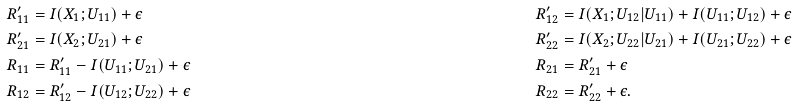<formula> <loc_0><loc_0><loc_500><loc_500>R _ { 1 1 } ^ { \prime } & = I ( X _ { 1 } ; U _ { 1 1 } ) + \epsilon & R _ { 1 2 } ^ { \prime } & = I ( X _ { 1 } ; U _ { 1 2 } | U _ { 1 1 } ) + I ( U _ { 1 1 } ; U _ { 1 2 } ) + \epsilon \\ R _ { 2 1 } ^ { \prime } & = I ( X _ { 2 } ; U _ { 2 1 } ) + \epsilon & R _ { 2 2 } ^ { \prime } & = I ( X _ { 2 } ; U _ { 2 2 } | U _ { 2 1 } ) + I ( U _ { 2 1 } ; U _ { 2 2 } ) + \epsilon \\ R _ { 1 1 } & = R _ { 1 1 } ^ { \prime } - I ( U _ { 1 1 } ; U _ { 2 1 } ) + \epsilon & R _ { 2 1 } & = R _ { 2 1 } ^ { \prime } + \epsilon \\ R _ { 1 2 } & = R _ { 1 2 } ^ { \prime } - I ( U _ { 1 2 } ; U _ { 2 2 } ) + \epsilon & R _ { 2 2 } & = R _ { 2 2 } ^ { \prime } + \epsilon .</formula> 